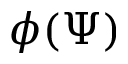<formula> <loc_0><loc_0><loc_500><loc_500>\phi ( \Psi )</formula> 